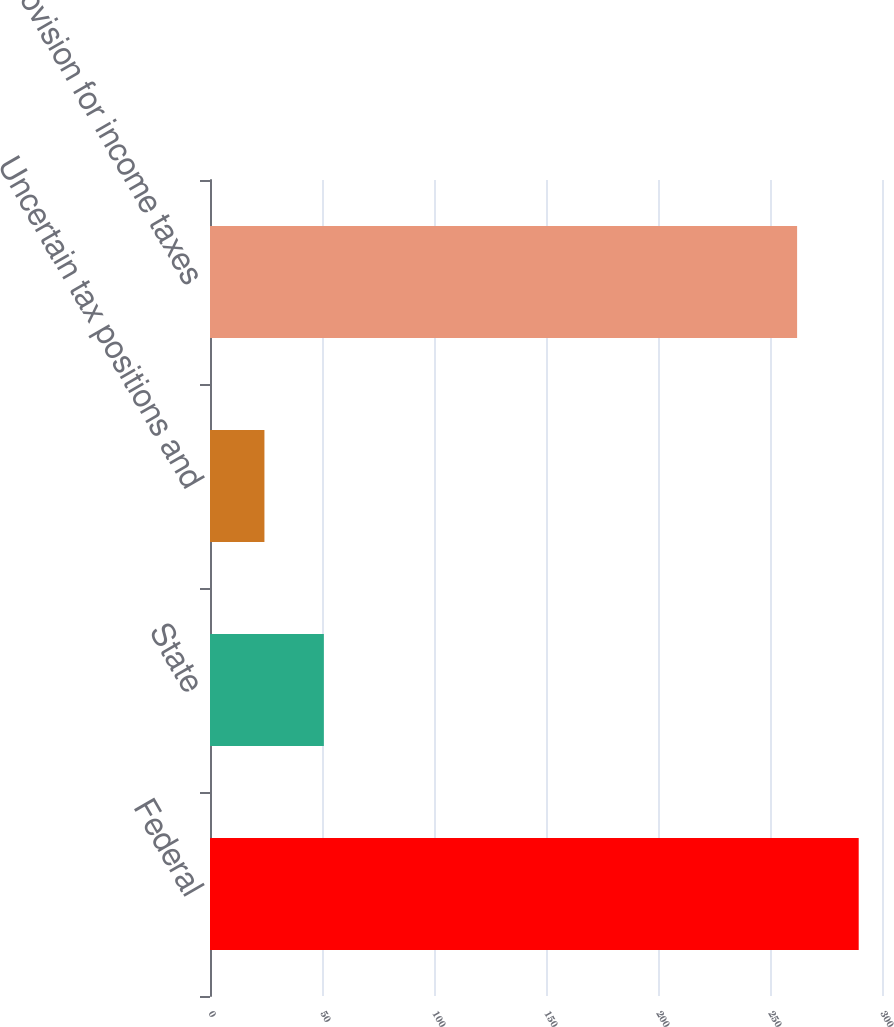<chart> <loc_0><loc_0><loc_500><loc_500><bar_chart><fcel>Federal<fcel>State<fcel>Uncertain tax positions and<fcel>Provision for income taxes<nl><fcel>289.6<fcel>50.83<fcel>24.3<fcel>262.1<nl></chart> 